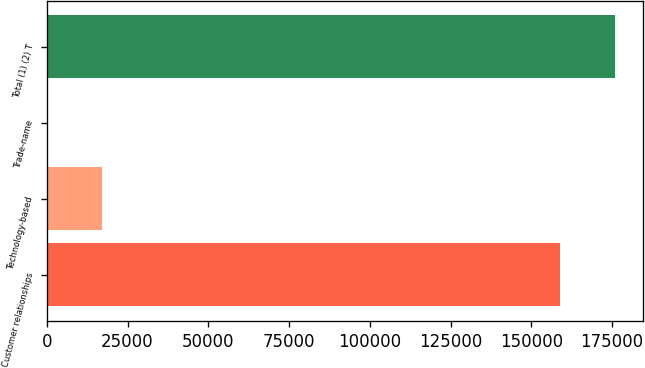<chart> <loc_0><loc_0><loc_500><loc_500><bar_chart><fcel>Customer relationships<fcel>Technology-based<fcel>Trade-name<fcel>Total (1) (2) T<nl><fcel>158979<fcel>16953.7<fcel>60<fcel>175873<nl></chart> 